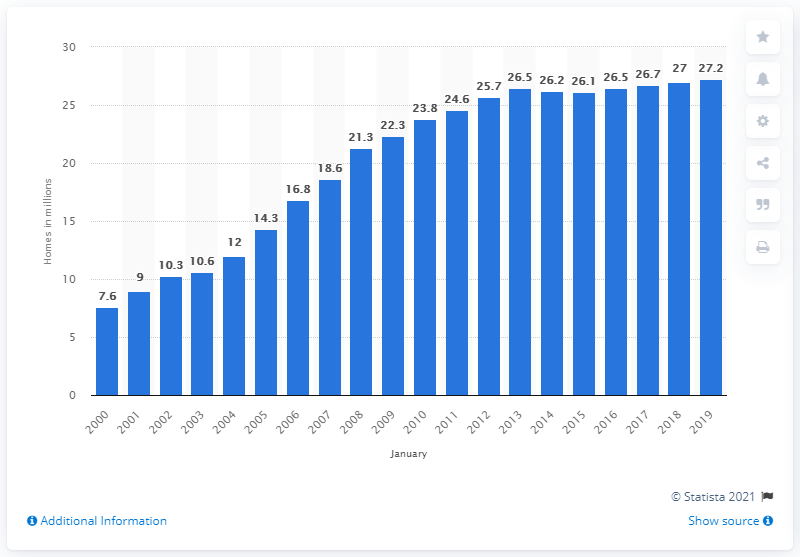Point out several critical features in this image. In the UK between 2000 and 2019, there were 7.6 million multichannel television homes. Between 2000 and 2019, the number of multichannel television homes in the UK increased from 27.2 to 30.9 million. 